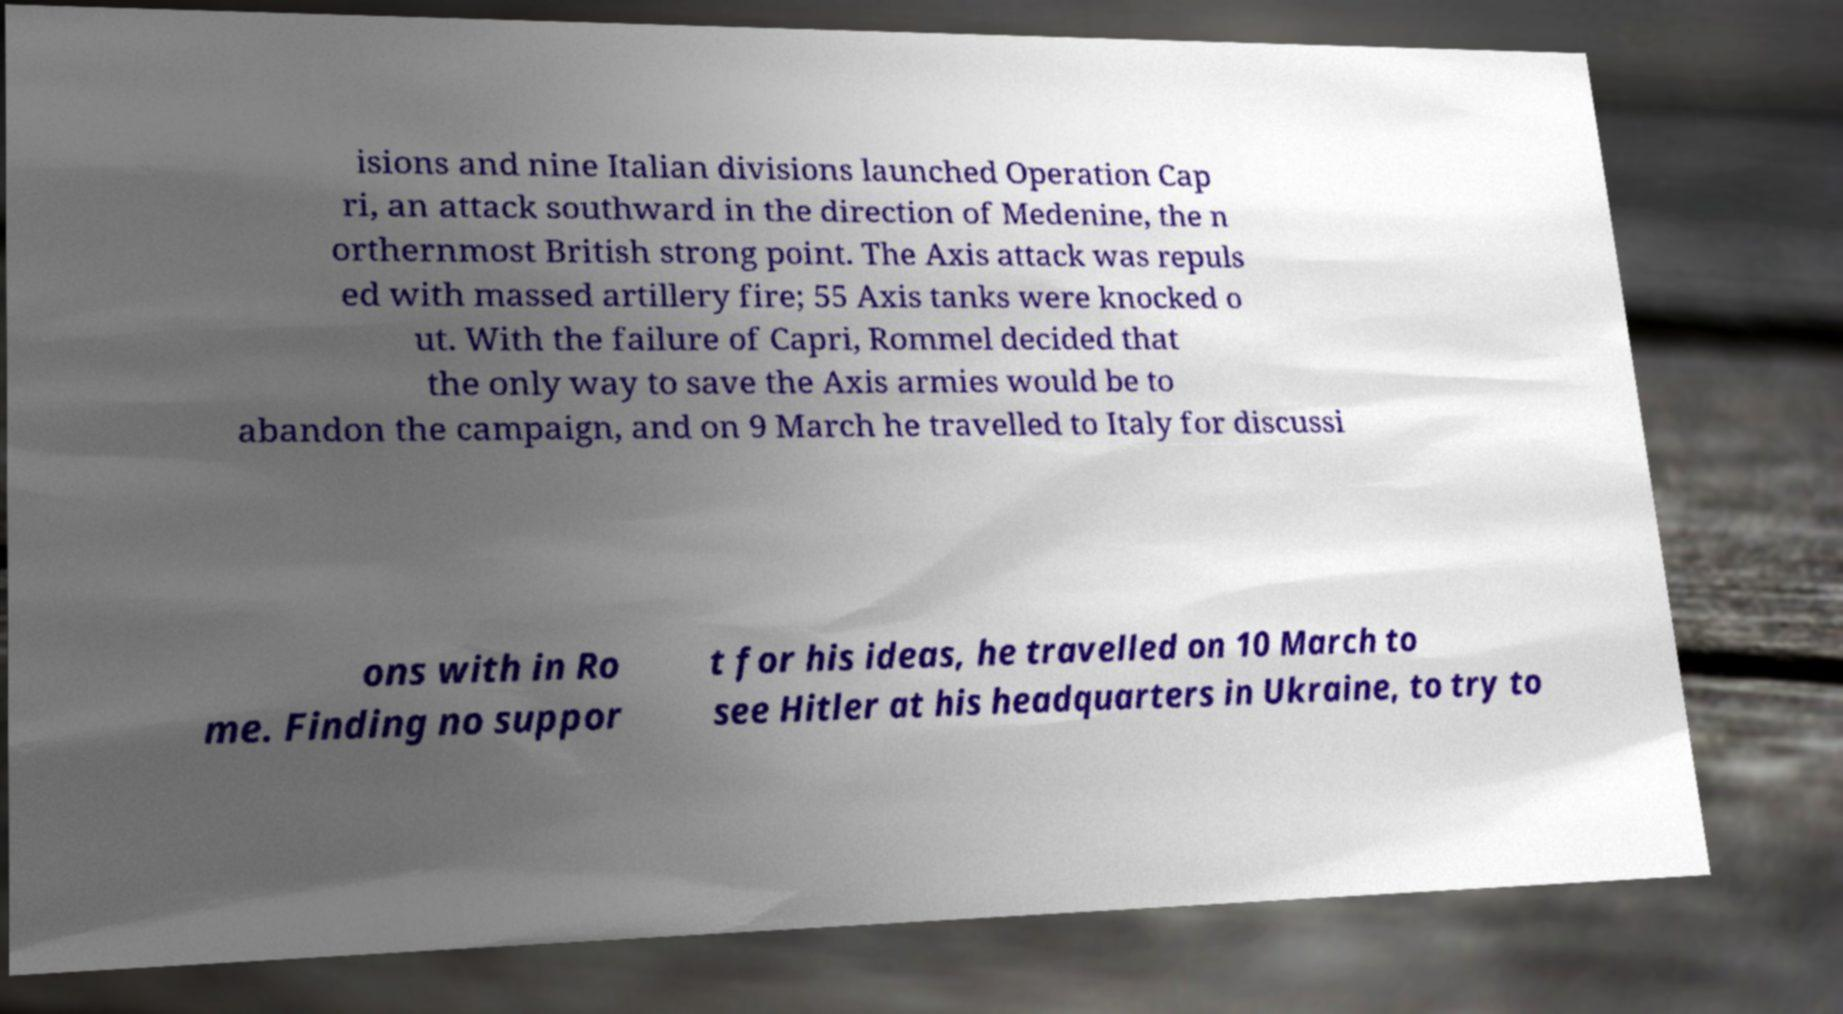Can you accurately transcribe the text from the provided image for me? isions and nine Italian divisions launched Operation Cap ri, an attack southward in the direction of Medenine, the n orthernmost British strong point. The Axis attack was repuls ed with massed artillery fire; 55 Axis tanks were knocked o ut. With the failure of Capri, Rommel decided that the only way to save the Axis armies would be to abandon the campaign, and on 9 March he travelled to Italy for discussi ons with in Ro me. Finding no suppor t for his ideas, he travelled on 10 March to see Hitler at his headquarters in Ukraine, to try to 